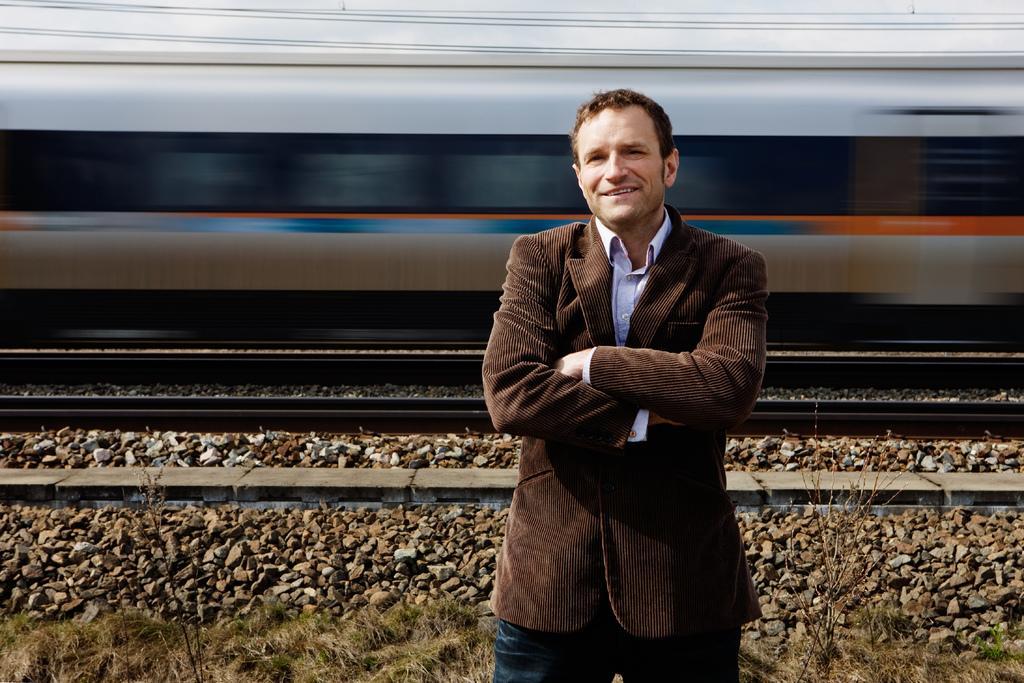Please provide a concise description of this image. Here in this picture we can see a person standing on the ground over there and he is smiling and he is wearing a coat on him and we can see grass present on the ground over there and behind him we can see train present on the track over there and we can see stones present all over there. 